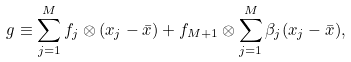<formula> <loc_0><loc_0><loc_500><loc_500>g \equiv \sum _ { j = 1 } ^ { M } f _ { j } \otimes ( x _ { j } - \bar { x } ) + f _ { M + 1 } \otimes \sum _ { j = 1 } ^ { M } \beta _ { j } ( x _ { j } - \bar { x } ) ,</formula> 